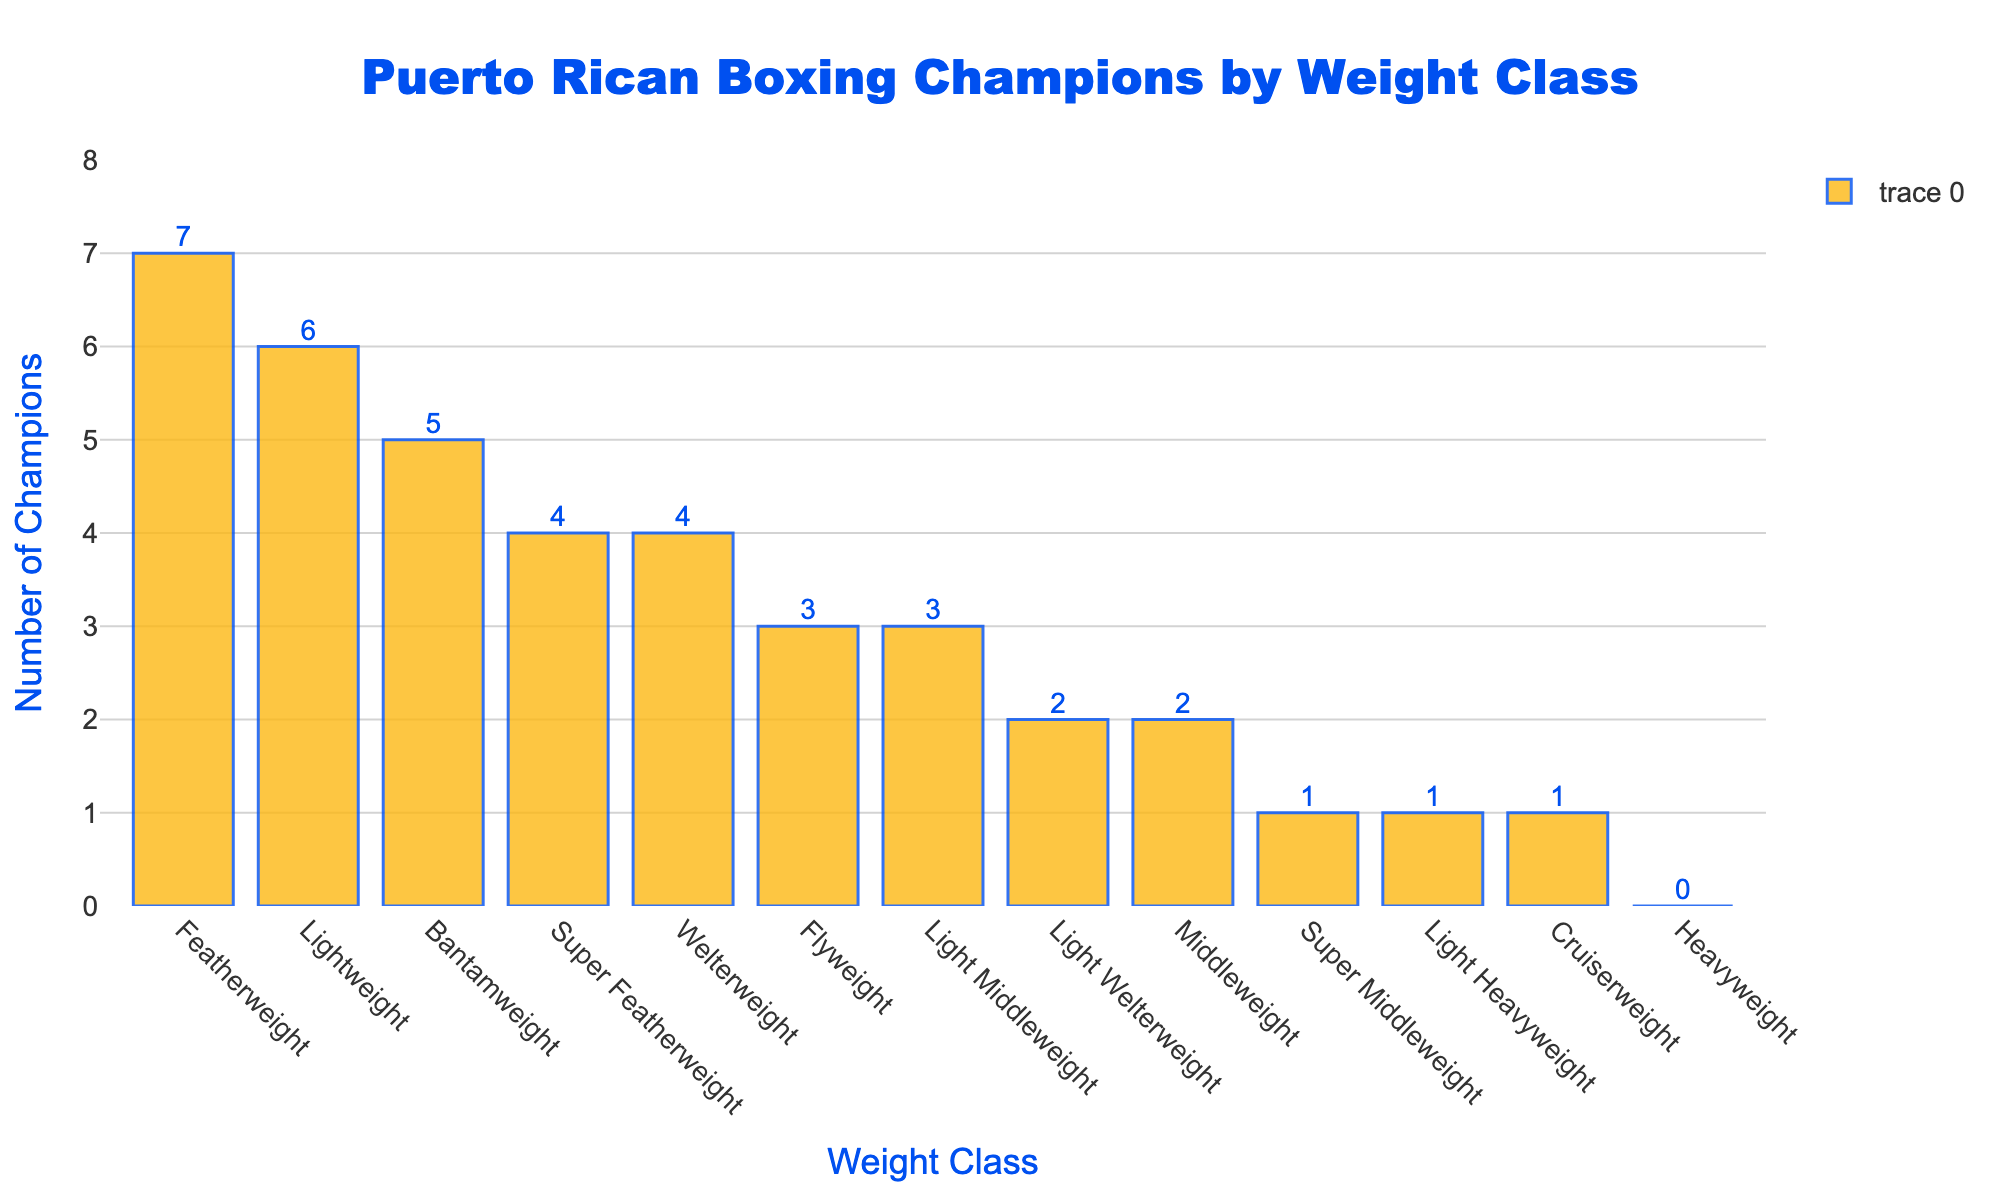Which weight class has the most Puerto Rican boxing champions? The tallest bar in the chart represents the weight class with the most champions. By looking at the chart, the Featherweight class has the highest bar.
Answer: Featherweight How many more champions are there in the Lightweight class than in the Light Welterweight class? The number of champions in the Lightweight class is 6 and in the Light Welterweight class is 2. The difference is 6 - 2 = 4.
Answer: 4 Which three weight classes have only one Puerto Rican boxing champion each? By observing the height of the bars and the numbers on top, the weight classes with bars indicating one champion are Super Middleweight, Light Heavyweight, and Cruiserweight.
Answer: Super Middleweight, Light Heavyweight, Cruiserweight What is the total number of champions in classes heavier than Welterweight? The classes heavier than Welterweight are Light Middleweight (3), Middleweight (2), Super Middleweight (1), Light Heavyweight (1), Cruiserweight (1), and Heavyweight (0). Summing them up: 3 + 2 + 1 + 1 + 1 + 0 = 8.
Answer: 8 How does the number of champions in the Featherweight class compare to the combined total of Flyweight and Bantamweight classes? The Featherweight class has 7 champions. Flyweight has 3 champions and Bantamweight has 5 champions. The combined total for Flyweight and Bantamweight is 3 + 5 = 8. So, Featherweight has 1 less champion compared to the combined total of Flyweight and Bantamweight (8 - 7 = 1).
Answer: Featherweight has 1 less Which weight class has no Puerto Rican boxing champions? The bar representing Heavyweight class has a height corresponding to 0 champions, as indicated in the chart.
Answer: Heavyweight What is the average number of champions per weight class? There are 13 weight classes with a total number of champions being 35. The average is calculated as 35 / 13 ≈ 2.69.
Answer: 2.69 How many weight classes have more than 4 champions? The weight classes with more than 4 champions are Bantamweight (5), Featherweight (7), and Lightweight (6), which makes a total of 3 classes.
Answer: 3 